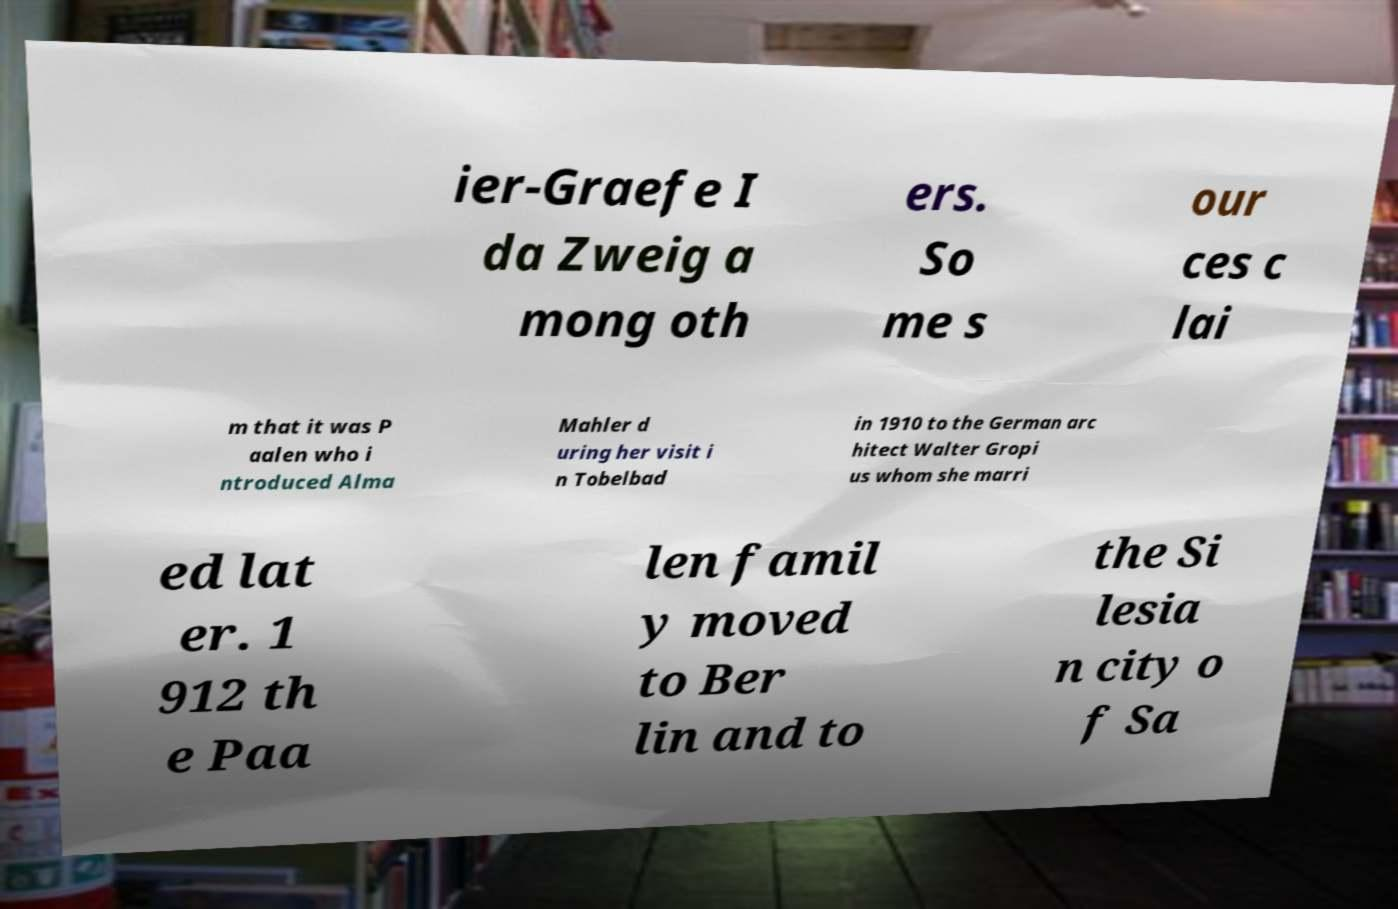Can you accurately transcribe the text from the provided image for me? ier-Graefe I da Zweig a mong oth ers. So me s our ces c lai m that it was P aalen who i ntroduced Alma Mahler d uring her visit i n Tobelbad in 1910 to the German arc hitect Walter Gropi us whom she marri ed lat er. 1 912 th e Paa len famil y moved to Ber lin and to the Si lesia n city o f Sa 